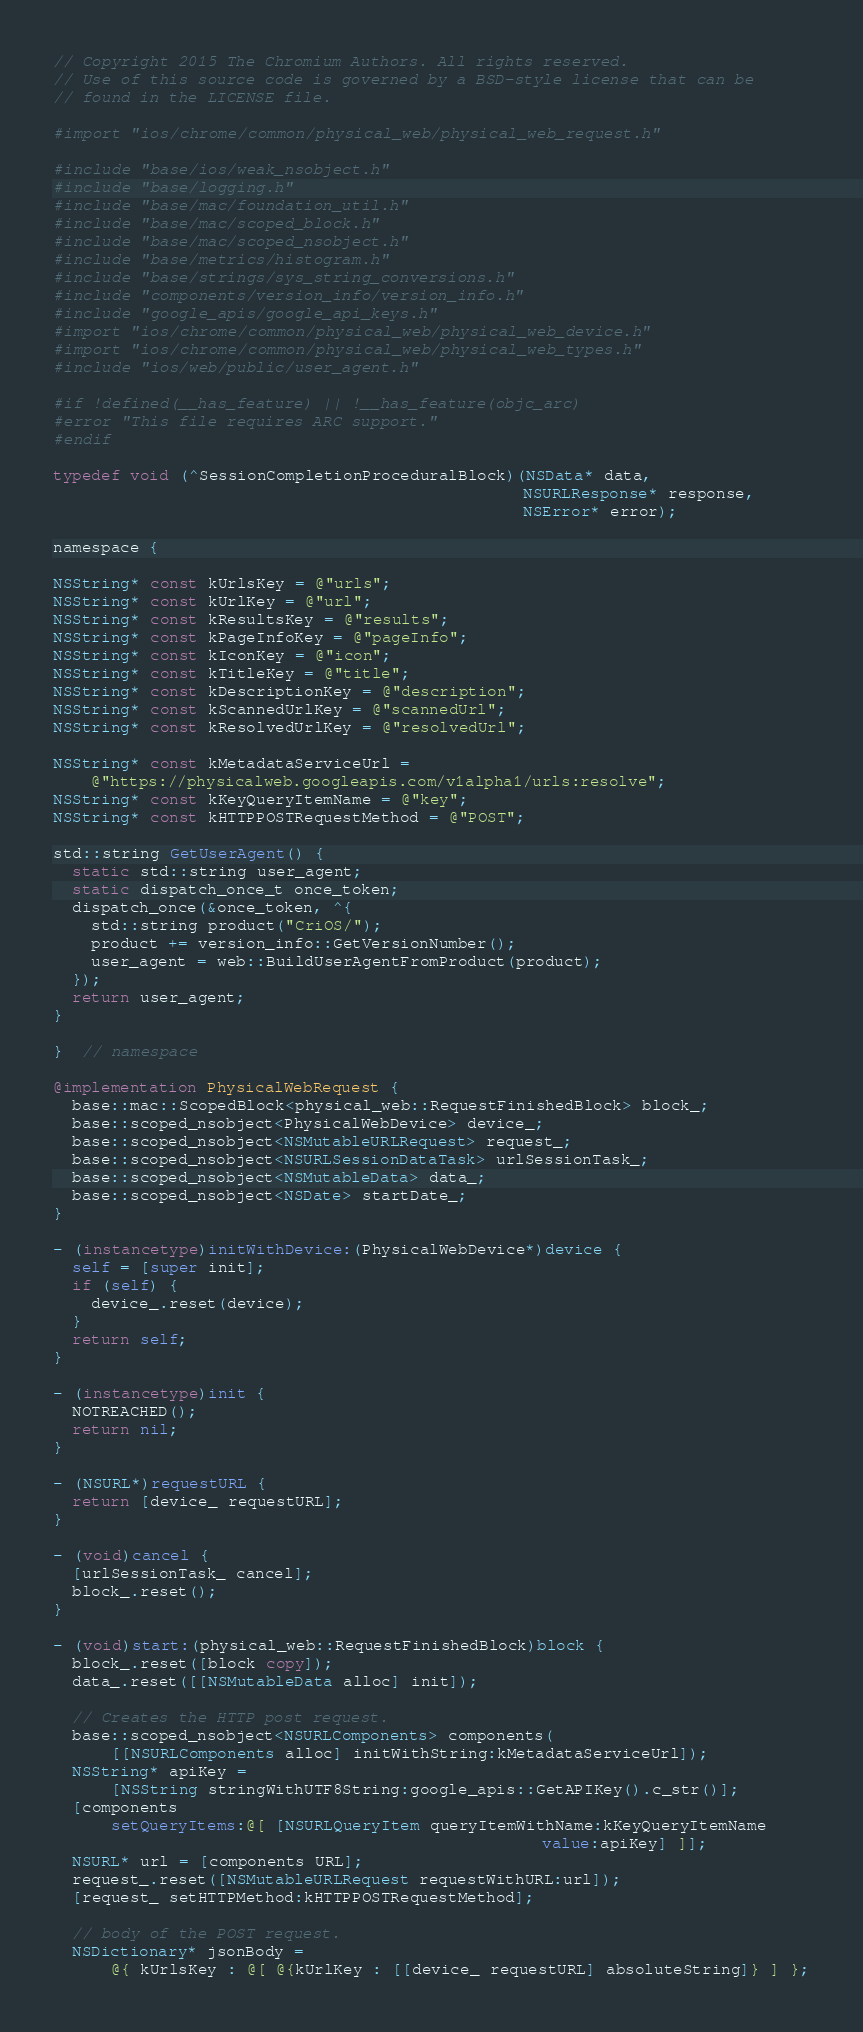Convert code to text. <code><loc_0><loc_0><loc_500><loc_500><_ObjectiveC_>// Copyright 2015 The Chromium Authors. All rights reserved.
// Use of this source code is governed by a BSD-style license that can be
// found in the LICENSE file.

#import "ios/chrome/common/physical_web/physical_web_request.h"

#include "base/ios/weak_nsobject.h"
#include "base/logging.h"
#include "base/mac/foundation_util.h"
#include "base/mac/scoped_block.h"
#include "base/mac/scoped_nsobject.h"
#include "base/metrics/histogram.h"
#include "base/strings/sys_string_conversions.h"
#include "components/version_info/version_info.h"
#include "google_apis/google_api_keys.h"
#import "ios/chrome/common/physical_web/physical_web_device.h"
#import "ios/chrome/common/physical_web/physical_web_types.h"
#include "ios/web/public/user_agent.h"

#if !defined(__has_feature) || !__has_feature(objc_arc)
#error "This file requires ARC support."
#endif

typedef void (^SessionCompletionProceduralBlock)(NSData* data,
                                                 NSURLResponse* response,
                                                 NSError* error);

namespace {

NSString* const kUrlsKey = @"urls";
NSString* const kUrlKey = @"url";
NSString* const kResultsKey = @"results";
NSString* const kPageInfoKey = @"pageInfo";
NSString* const kIconKey = @"icon";
NSString* const kTitleKey = @"title";
NSString* const kDescriptionKey = @"description";
NSString* const kScannedUrlKey = @"scannedUrl";
NSString* const kResolvedUrlKey = @"resolvedUrl";

NSString* const kMetadataServiceUrl =
    @"https://physicalweb.googleapis.com/v1alpha1/urls:resolve";
NSString* const kKeyQueryItemName = @"key";
NSString* const kHTTPPOSTRequestMethod = @"POST";

std::string GetUserAgent() {
  static std::string user_agent;
  static dispatch_once_t once_token;
  dispatch_once(&once_token, ^{
    std::string product("CriOS/");
    product += version_info::GetVersionNumber();
    user_agent = web::BuildUserAgentFromProduct(product);
  });
  return user_agent;
}

}  // namespace

@implementation PhysicalWebRequest {
  base::mac::ScopedBlock<physical_web::RequestFinishedBlock> block_;
  base::scoped_nsobject<PhysicalWebDevice> device_;
  base::scoped_nsobject<NSMutableURLRequest> request_;
  base::scoped_nsobject<NSURLSessionDataTask> urlSessionTask_;
  base::scoped_nsobject<NSMutableData> data_;
  base::scoped_nsobject<NSDate> startDate_;
}

- (instancetype)initWithDevice:(PhysicalWebDevice*)device {
  self = [super init];
  if (self) {
    device_.reset(device);
  }
  return self;
}

- (instancetype)init {
  NOTREACHED();
  return nil;
}

- (NSURL*)requestURL {
  return [device_ requestURL];
}

- (void)cancel {
  [urlSessionTask_ cancel];
  block_.reset();
}

- (void)start:(physical_web::RequestFinishedBlock)block {
  block_.reset([block copy]);
  data_.reset([[NSMutableData alloc] init]);

  // Creates the HTTP post request.
  base::scoped_nsobject<NSURLComponents> components(
      [[NSURLComponents alloc] initWithString:kMetadataServiceUrl]);
  NSString* apiKey =
      [NSString stringWithUTF8String:google_apis::GetAPIKey().c_str()];
  [components
      setQueryItems:@[ [NSURLQueryItem queryItemWithName:kKeyQueryItemName
                                                   value:apiKey] ]];
  NSURL* url = [components URL];
  request_.reset([NSMutableURLRequest requestWithURL:url]);
  [request_ setHTTPMethod:kHTTPPOSTRequestMethod];

  // body of the POST request.
  NSDictionary* jsonBody =
      @{ kUrlsKey : @[ @{kUrlKey : [[device_ requestURL] absoluteString]} ] };</code> 